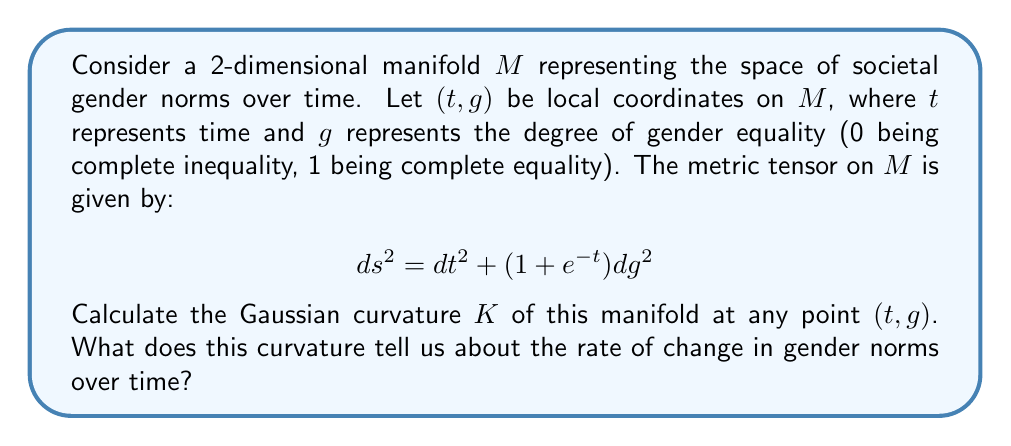What is the answer to this math problem? To calculate the Gaussian curvature, we'll use the following steps:

1) First, we need to identify the components of the metric tensor:
   $g_{11} = 1$, $g_{12} = g_{21} = 0$, $g_{22} = 1 + e^{-t}$

2) We'll use the formula for Gaussian curvature in 2D:
   $$K = -\frac{1}{\sqrt{g}}\left(\frac{\partial}{\partial t}\left(\frac{\sqrt{g}}{g_{11}}g^{11}\Gamma^1_{12}\right) + \frac{\partial}{\partial g}\left(\frac{\sqrt{g}}{g_{11}}g^{11}\Gamma^1_{22}\right)\right)$$

   where $g = \det(g_{ij}) = 1 + e^{-t}$, and $\Gamma^i_{jk}$ are the Christoffel symbols.

3) Calculate the Christoffel symbols:
   $\Gamma^1_{12} = \Gamma^1_{21} = 0$
   $\Gamma^1_{22} = \frac{1}{2}e^{-t}$
   $\Gamma^2_{12} = \Gamma^2_{21} = \frac{1}{2}\frac{e^{-t}}{1+e^{-t}}$

4) Substitute into the curvature formula:
   $$K = -\frac{1}{\sqrt{1+e^{-t}}}\frac{\partial}{\partial g}\left(\frac{\sqrt{1+e^{-t}}}{1} \cdot 1 \cdot \frac{1}{2}e^{-t}\right)$$

5) Simplify:
   $$K = -\frac{1}{\sqrt{1+e^{-t}}} \cdot 0 = 0$$

The Gaussian curvature is zero everywhere on the manifold. This indicates that the manifold is locally flat, meaning that the rate of change in gender norms (as modeled by this manifold) is constant over time. However, the metric itself shows that the "distance" between different levels of gender equality decreases exponentially over time, suggesting that changes in gender norms become more difficult to achieve as time progresses.
Answer: The Gaussian curvature $K = 0$ at all points $(t, g)$ on the manifold. 